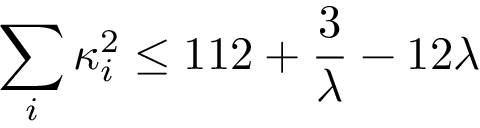<formula> <loc_0><loc_0><loc_500><loc_500>\sum _ { i } \kappa _ { i } ^ { 2 } \leq 1 1 2 + { \frac { 3 } { \lambda } } - 1 2 \lambda</formula> 